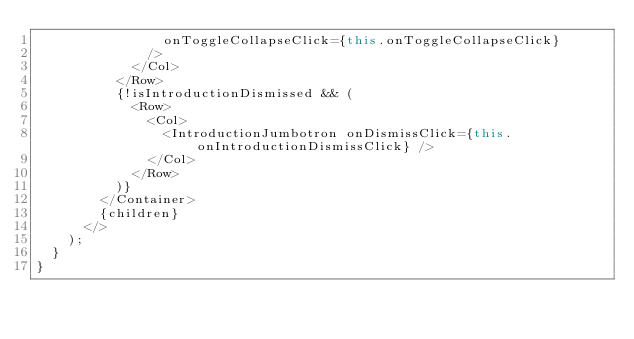<code> <loc_0><loc_0><loc_500><loc_500><_JavaScript_>                onToggleCollapseClick={this.onToggleCollapseClick}
              />
            </Col>
          </Row>
          {!isIntroductionDismissed && (
            <Row>
              <Col>
                <IntroductionJumbotron onDismissClick={this.onIntroductionDismissClick} />
              </Col>
            </Row>
          )}
        </Container>
        {children}
      </>
    );
  }
}
</code> 